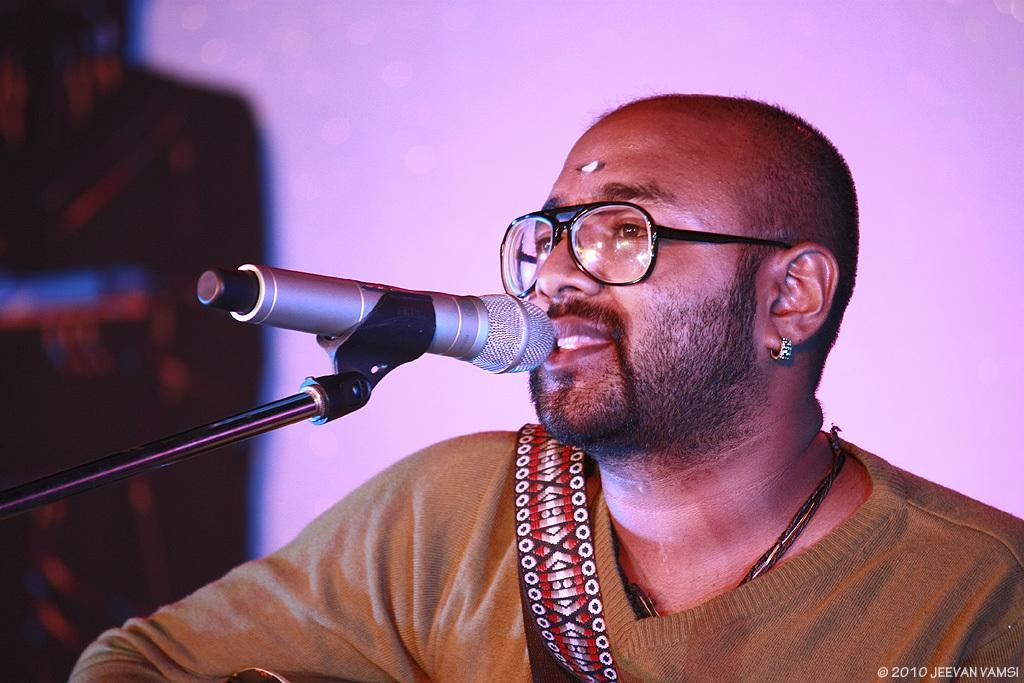What can be found in the bottom right corner of the image? There is a watermark in the bottom right corner of the image. What is the person in the image wearing? The person is wearing a t-shirt in the image. What is the person doing in the image? The person is singing in the image. What is the person holding while singing? The person is holding a microphone in the image. How is the microphone positioned in the image? The microphone is attached to a stand in the image. What can be observed about the background of the image? The background of the image is blurred. How does the person in the image measure the length of the microphone stand? There is no indication in the image that the person is measuring the length of the microphone stand. 